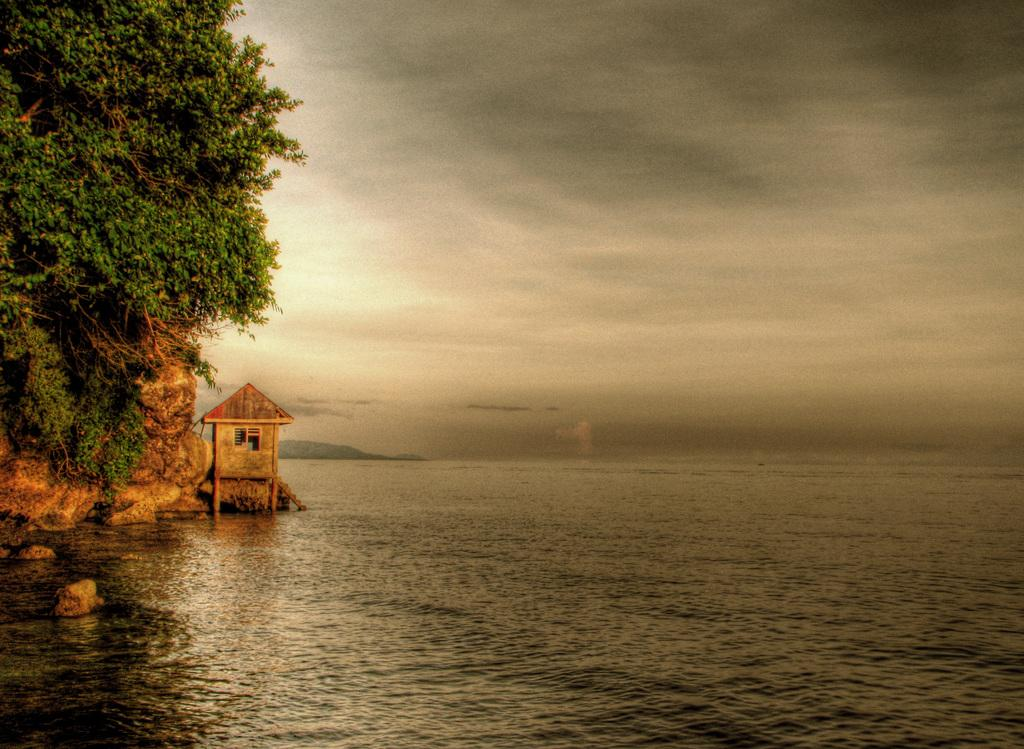What type of natural feature is present in the image? There is an ocean in the image. What can be seen on the left side of the image? There are trees and a wooden cabin on the left side of the image. What is visible in the background of the image? There is a sky visible in the background of the image. What can be observed in the sky? There are clouds in the sky. Where are the toys located in the image? There are no toys present in the image. Can you tell me how many horses are visible in the image? There are no horses visible in the image. 